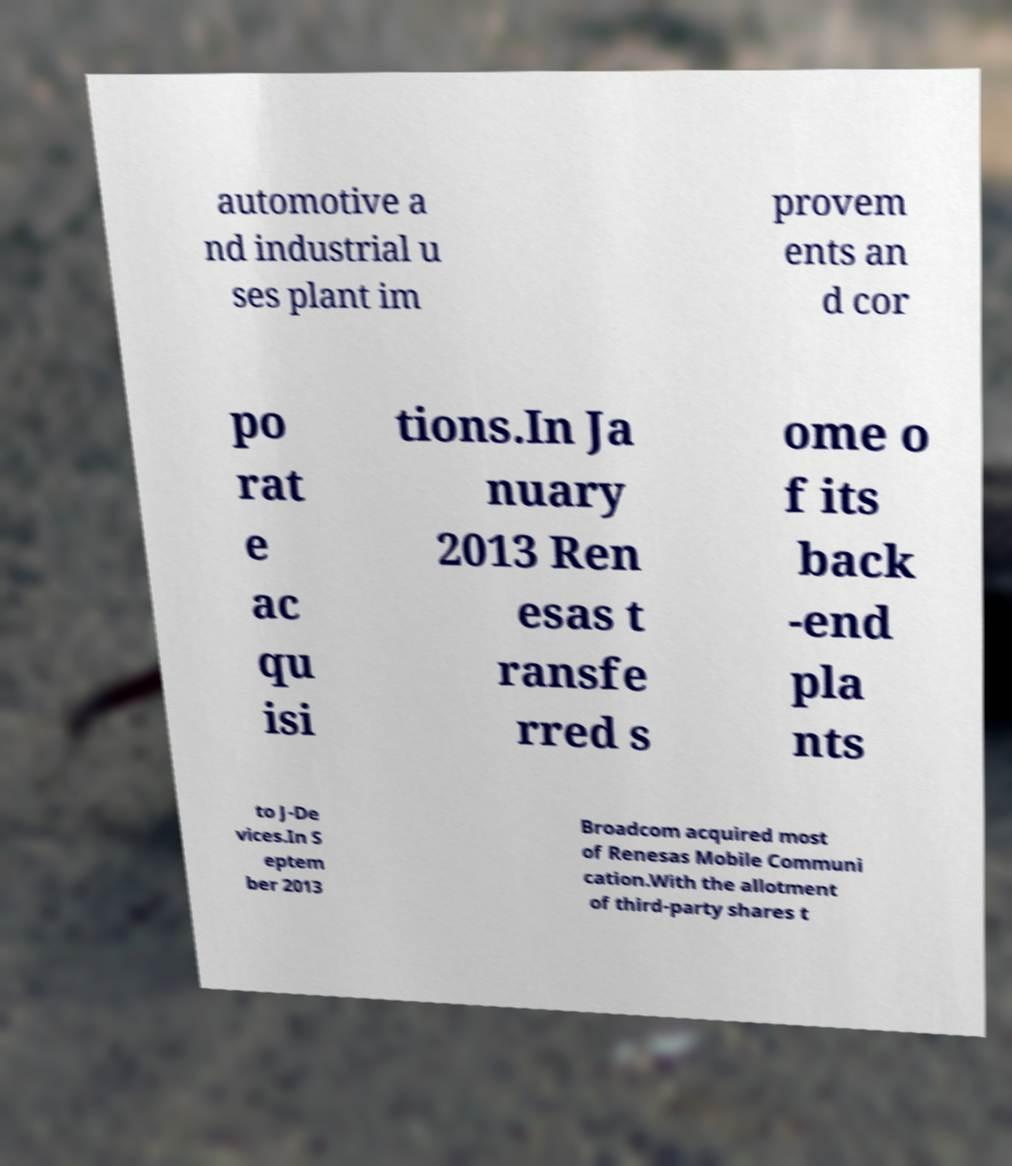Please identify and transcribe the text found in this image. automotive a nd industrial u ses plant im provem ents an d cor po rat e ac qu isi tions.In Ja nuary 2013 Ren esas t ransfe rred s ome o f its back -end pla nts to J-De vices.In S eptem ber 2013 Broadcom acquired most of Renesas Mobile Communi cation.With the allotment of third-party shares t 